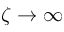Convert formula to latex. <formula><loc_0><loc_0><loc_500><loc_500>\zeta \rightarrow \infty</formula> 